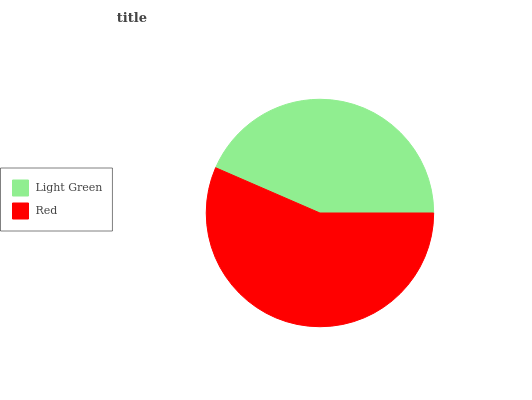Is Light Green the minimum?
Answer yes or no. Yes. Is Red the maximum?
Answer yes or no. Yes. Is Red the minimum?
Answer yes or no. No. Is Red greater than Light Green?
Answer yes or no. Yes. Is Light Green less than Red?
Answer yes or no. Yes. Is Light Green greater than Red?
Answer yes or no. No. Is Red less than Light Green?
Answer yes or no. No. Is Red the high median?
Answer yes or no. Yes. Is Light Green the low median?
Answer yes or no. Yes. Is Light Green the high median?
Answer yes or no. No. Is Red the low median?
Answer yes or no. No. 